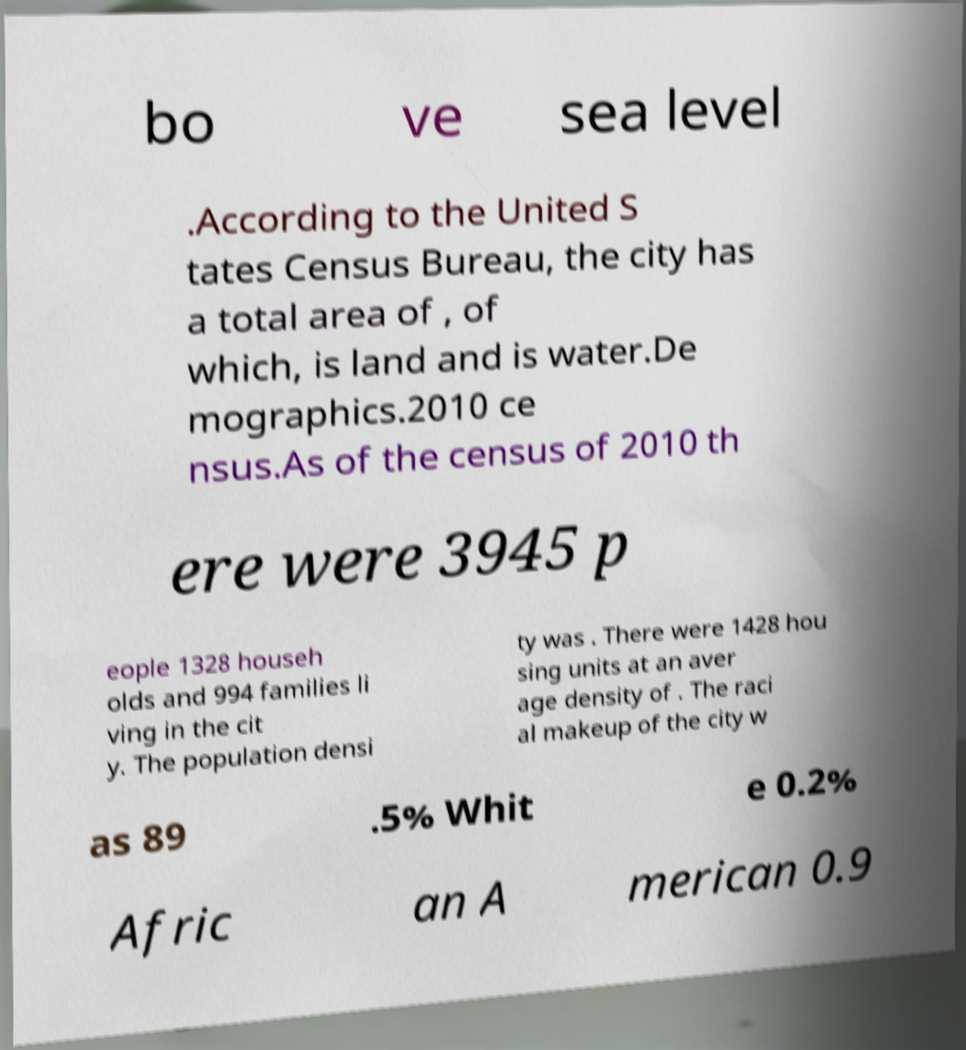Please read and relay the text visible in this image. What does it say? bo ve sea level .According to the United S tates Census Bureau, the city has a total area of , of which, is land and is water.De mographics.2010 ce nsus.As of the census of 2010 th ere were 3945 p eople 1328 househ olds and 994 families li ving in the cit y. The population densi ty was . There were 1428 hou sing units at an aver age density of . The raci al makeup of the city w as 89 .5% Whit e 0.2% Afric an A merican 0.9 